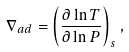Convert formula to latex. <formula><loc_0><loc_0><loc_500><loc_500>\nabla _ { a d } = \left ( \frac { \partial \ln T } { \partial \ln P } \right ) _ { s } ,</formula> 